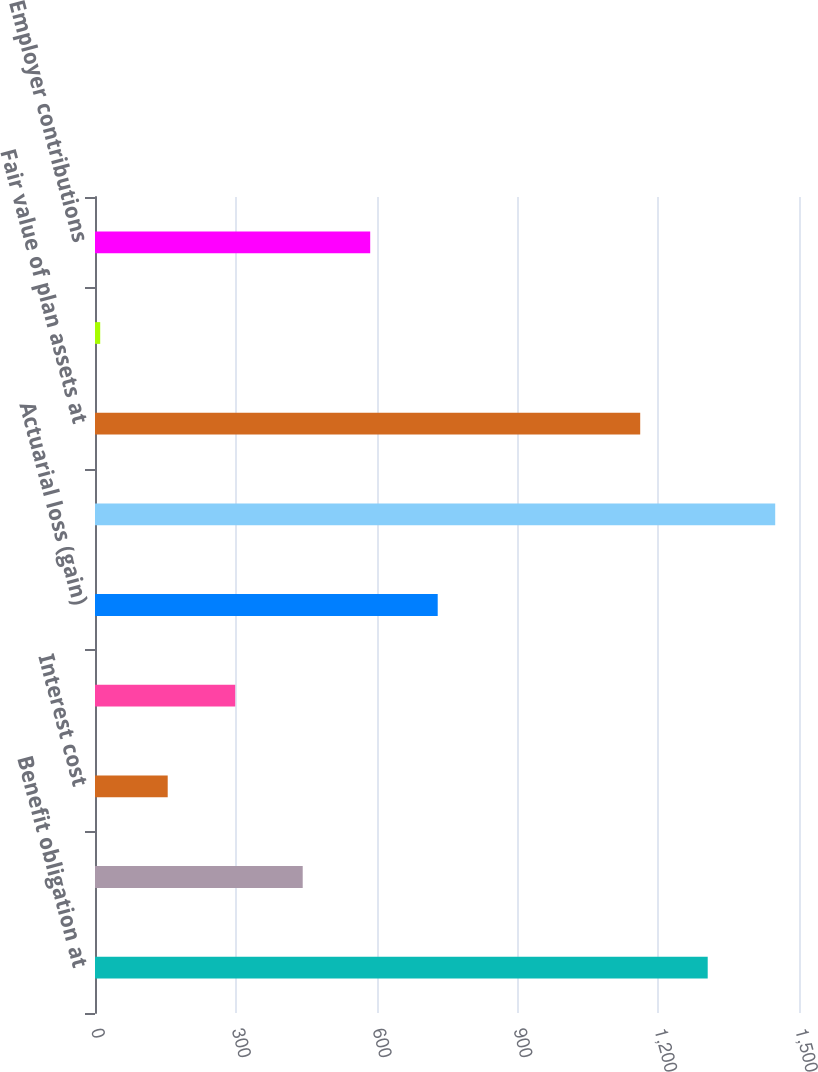Convert chart to OTSL. <chart><loc_0><loc_0><loc_500><loc_500><bar_chart><fcel>Benefit obligation at<fcel>Service cost<fcel>Interest cost<fcel>Benefits and other expenses<fcel>Actuarial loss (gain)<fcel>Benefit obligation at end of<fcel>Fair value of plan assets at<fcel>Actual return on plan assets<fcel>Employer contributions<nl><fcel>1305.48<fcel>442.56<fcel>154.92<fcel>298.74<fcel>730.2<fcel>1449.3<fcel>1161.66<fcel>11.1<fcel>586.38<nl></chart> 